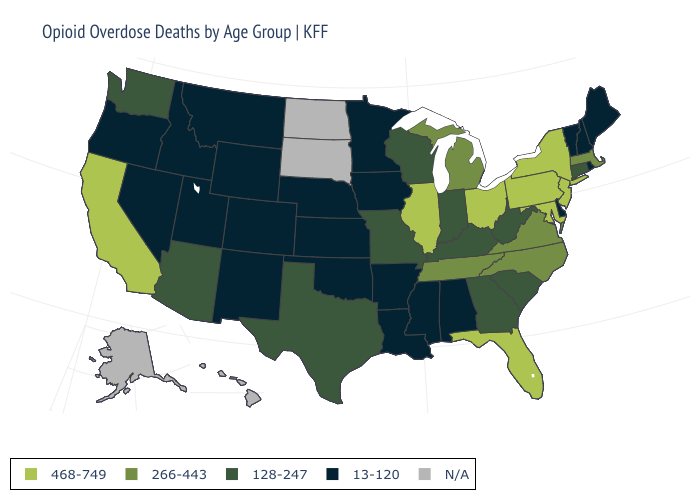Name the states that have a value in the range 128-247?
Write a very short answer. Arizona, Connecticut, Georgia, Indiana, Kentucky, Missouri, South Carolina, Texas, Washington, West Virginia, Wisconsin. Does the first symbol in the legend represent the smallest category?
Write a very short answer. No. What is the lowest value in the West?
Answer briefly. 13-120. Name the states that have a value in the range 266-443?
Short answer required. Massachusetts, Michigan, North Carolina, Tennessee, Virginia. What is the highest value in the USA?
Keep it brief. 468-749. What is the value of Rhode Island?
Answer briefly. 13-120. What is the highest value in states that border West Virginia?
Give a very brief answer. 468-749. Name the states that have a value in the range 128-247?
Answer briefly. Arizona, Connecticut, Georgia, Indiana, Kentucky, Missouri, South Carolina, Texas, Washington, West Virginia, Wisconsin. Does the first symbol in the legend represent the smallest category?
Short answer required. No. Which states hav the highest value in the MidWest?
Write a very short answer. Illinois, Ohio. Name the states that have a value in the range 128-247?
Give a very brief answer. Arizona, Connecticut, Georgia, Indiana, Kentucky, Missouri, South Carolina, Texas, Washington, West Virginia, Wisconsin. What is the value of California?
Write a very short answer. 468-749. Which states have the highest value in the USA?
Answer briefly. California, Florida, Illinois, Maryland, New Jersey, New York, Ohio, Pennsylvania. Which states have the lowest value in the USA?
Keep it brief. Alabama, Arkansas, Colorado, Delaware, Idaho, Iowa, Kansas, Louisiana, Maine, Minnesota, Mississippi, Montana, Nebraska, Nevada, New Hampshire, New Mexico, Oklahoma, Oregon, Rhode Island, Utah, Vermont, Wyoming. 